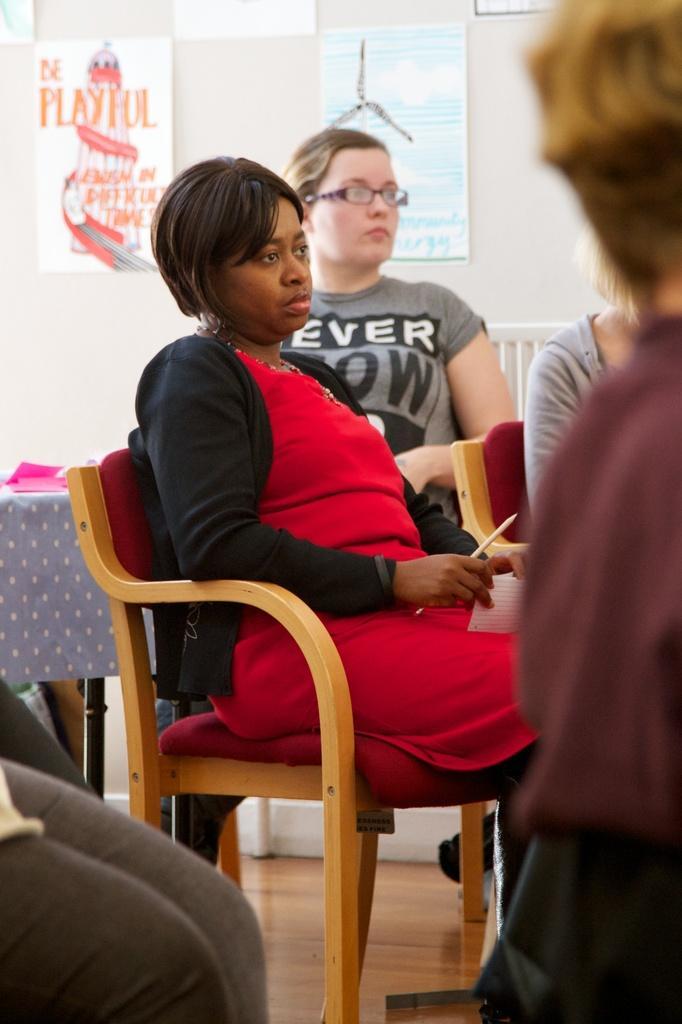Describe this image in one or two sentences. In this image there is a woman sitting in a chair. At the background there is a wall to which there is a label and painting is sticked. To the left side there is a table on which there are papers. To the right side there is another woman who is sitting on the chair. 